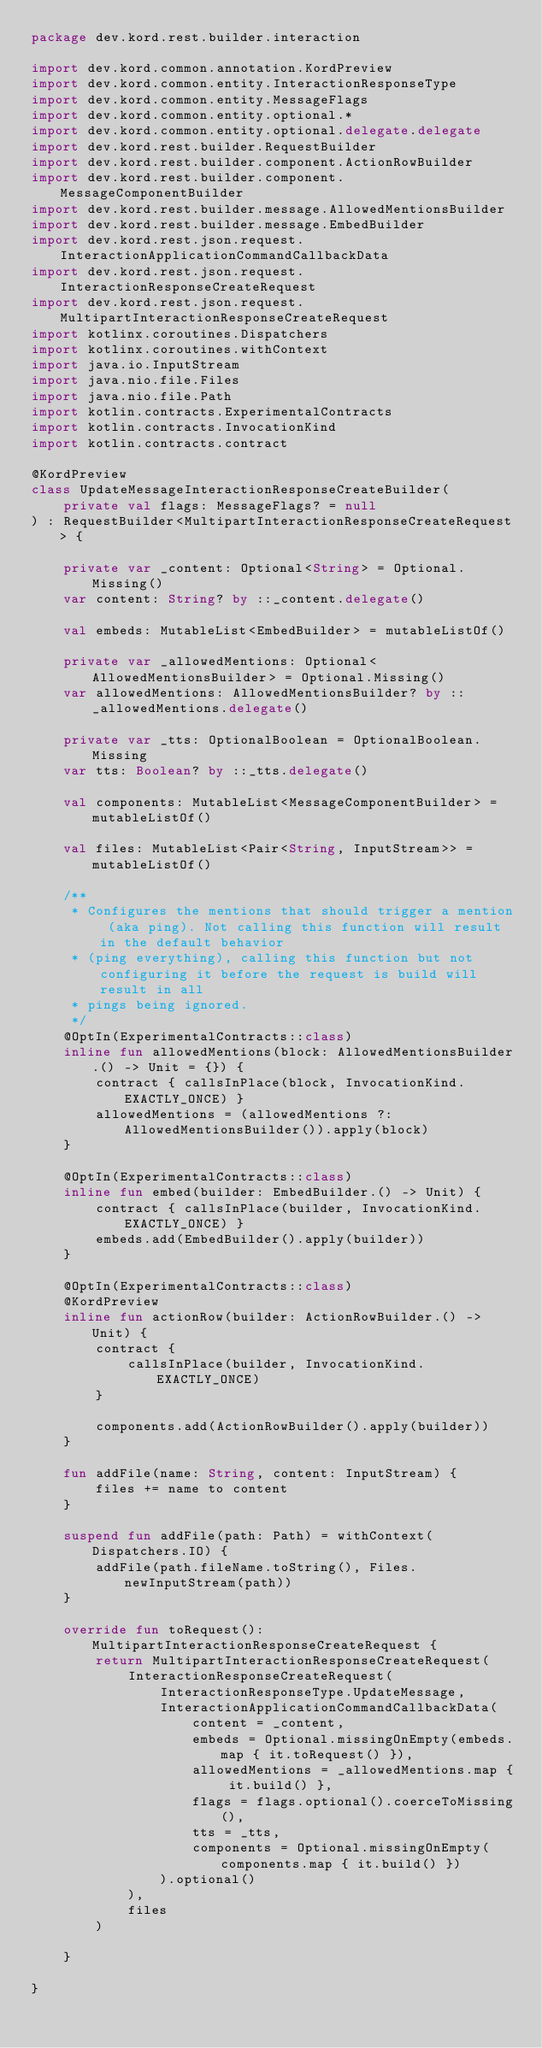<code> <loc_0><loc_0><loc_500><loc_500><_Kotlin_>package dev.kord.rest.builder.interaction

import dev.kord.common.annotation.KordPreview
import dev.kord.common.entity.InteractionResponseType
import dev.kord.common.entity.MessageFlags
import dev.kord.common.entity.optional.*
import dev.kord.common.entity.optional.delegate.delegate
import dev.kord.rest.builder.RequestBuilder
import dev.kord.rest.builder.component.ActionRowBuilder
import dev.kord.rest.builder.component.MessageComponentBuilder
import dev.kord.rest.builder.message.AllowedMentionsBuilder
import dev.kord.rest.builder.message.EmbedBuilder
import dev.kord.rest.json.request.InteractionApplicationCommandCallbackData
import dev.kord.rest.json.request.InteractionResponseCreateRequest
import dev.kord.rest.json.request.MultipartInteractionResponseCreateRequest
import kotlinx.coroutines.Dispatchers
import kotlinx.coroutines.withContext
import java.io.InputStream
import java.nio.file.Files
import java.nio.file.Path
import kotlin.contracts.ExperimentalContracts
import kotlin.contracts.InvocationKind
import kotlin.contracts.contract

@KordPreview
class UpdateMessageInteractionResponseCreateBuilder(
    private val flags: MessageFlags? = null
) : RequestBuilder<MultipartInteractionResponseCreateRequest> {

    private var _content: Optional<String> = Optional.Missing()
    var content: String? by ::_content.delegate()

    val embeds: MutableList<EmbedBuilder> = mutableListOf()

    private var _allowedMentions: Optional<AllowedMentionsBuilder> = Optional.Missing()
    var allowedMentions: AllowedMentionsBuilder? by ::_allowedMentions.delegate()

    private var _tts: OptionalBoolean = OptionalBoolean.Missing
    var tts: Boolean? by ::_tts.delegate()

    val components: MutableList<MessageComponentBuilder> = mutableListOf()

    val files: MutableList<Pair<String, InputStream>> = mutableListOf()

    /**
     * Configures the mentions that should trigger a mention (aka ping). Not calling this function will result in the default behavior
     * (ping everything), calling this function but not configuring it before the request is build will result in all
     * pings being ignored.
     */
    @OptIn(ExperimentalContracts::class)
    inline fun allowedMentions(block: AllowedMentionsBuilder.() -> Unit = {}) {
        contract { callsInPlace(block, InvocationKind.EXACTLY_ONCE) }
        allowedMentions = (allowedMentions ?: AllowedMentionsBuilder()).apply(block)
    }

    @OptIn(ExperimentalContracts::class)
    inline fun embed(builder: EmbedBuilder.() -> Unit) {
        contract { callsInPlace(builder, InvocationKind.EXACTLY_ONCE) }
        embeds.add(EmbedBuilder().apply(builder))
    }

    @OptIn(ExperimentalContracts::class)
    @KordPreview
    inline fun actionRow(builder: ActionRowBuilder.() -> Unit) {
        contract {
            callsInPlace(builder, InvocationKind.EXACTLY_ONCE)
        }

        components.add(ActionRowBuilder().apply(builder))
    }

    fun addFile(name: String, content: InputStream) {
        files += name to content
    }

    suspend fun addFile(path: Path) = withContext(Dispatchers.IO) {
        addFile(path.fileName.toString(), Files.newInputStream(path))
    }

    override fun toRequest(): MultipartInteractionResponseCreateRequest {
        return MultipartInteractionResponseCreateRequest(
            InteractionResponseCreateRequest(
                InteractionResponseType.UpdateMessage,
                InteractionApplicationCommandCallbackData(
                    content = _content,
                    embeds = Optional.missingOnEmpty(embeds.map { it.toRequest() }),
                    allowedMentions = _allowedMentions.map { it.build() },
                    flags = flags.optional().coerceToMissing(),
                    tts = _tts,
                    components = Optional.missingOnEmpty(components.map { it.build() })
                ).optional()
            ),
            files
        )

    }

}
</code> 